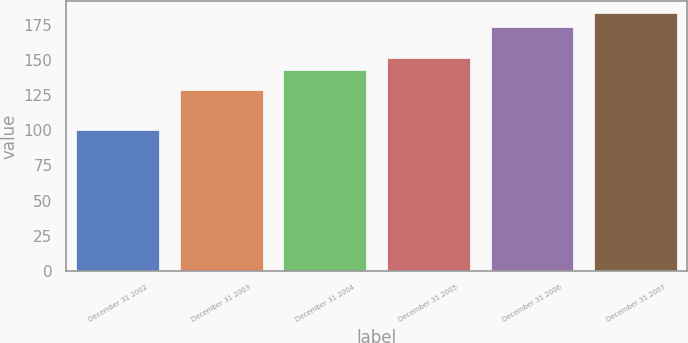Convert chart to OTSL. <chart><loc_0><loc_0><loc_500><loc_500><bar_chart><fcel>December 31 2002<fcel>December 31 2003<fcel>December 31 2004<fcel>December 31 2005<fcel>December 31 2006<fcel>December 31 2007<nl><fcel>100<fcel>128.68<fcel>142.69<fcel>150.98<fcel>173.34<fcel>182.87<nl></chart> 